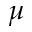Convert formula to latex. <formula><loc_0><loc_0><loc_500><loc_500>\mu</formula> 